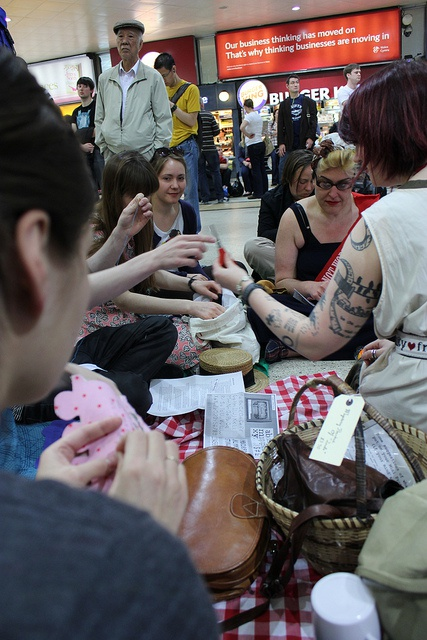Describe the objects in this image and their specific colors. I can see people in tan, black, gray, and darkgray tones, people in tan, black, darkgray, gray, and lightgray tones, people in tan, black, gray, and darkgray tones, handbag in tan, gray, black, and brown tones, and people in tan, black, gray, and maroon tones in this image. 